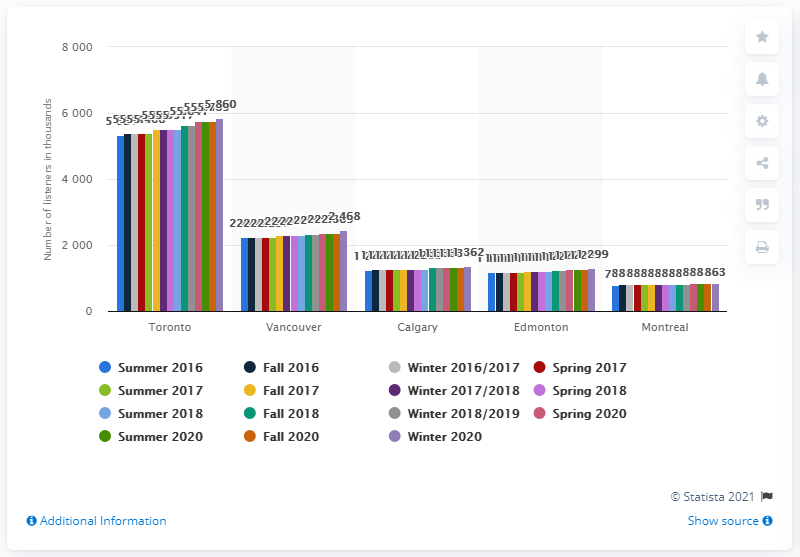Mention a couple of crucial points in this snapshot. According to the given information, Toronto is the leading radio market in the country with an average of over five million listeners each quarter. 